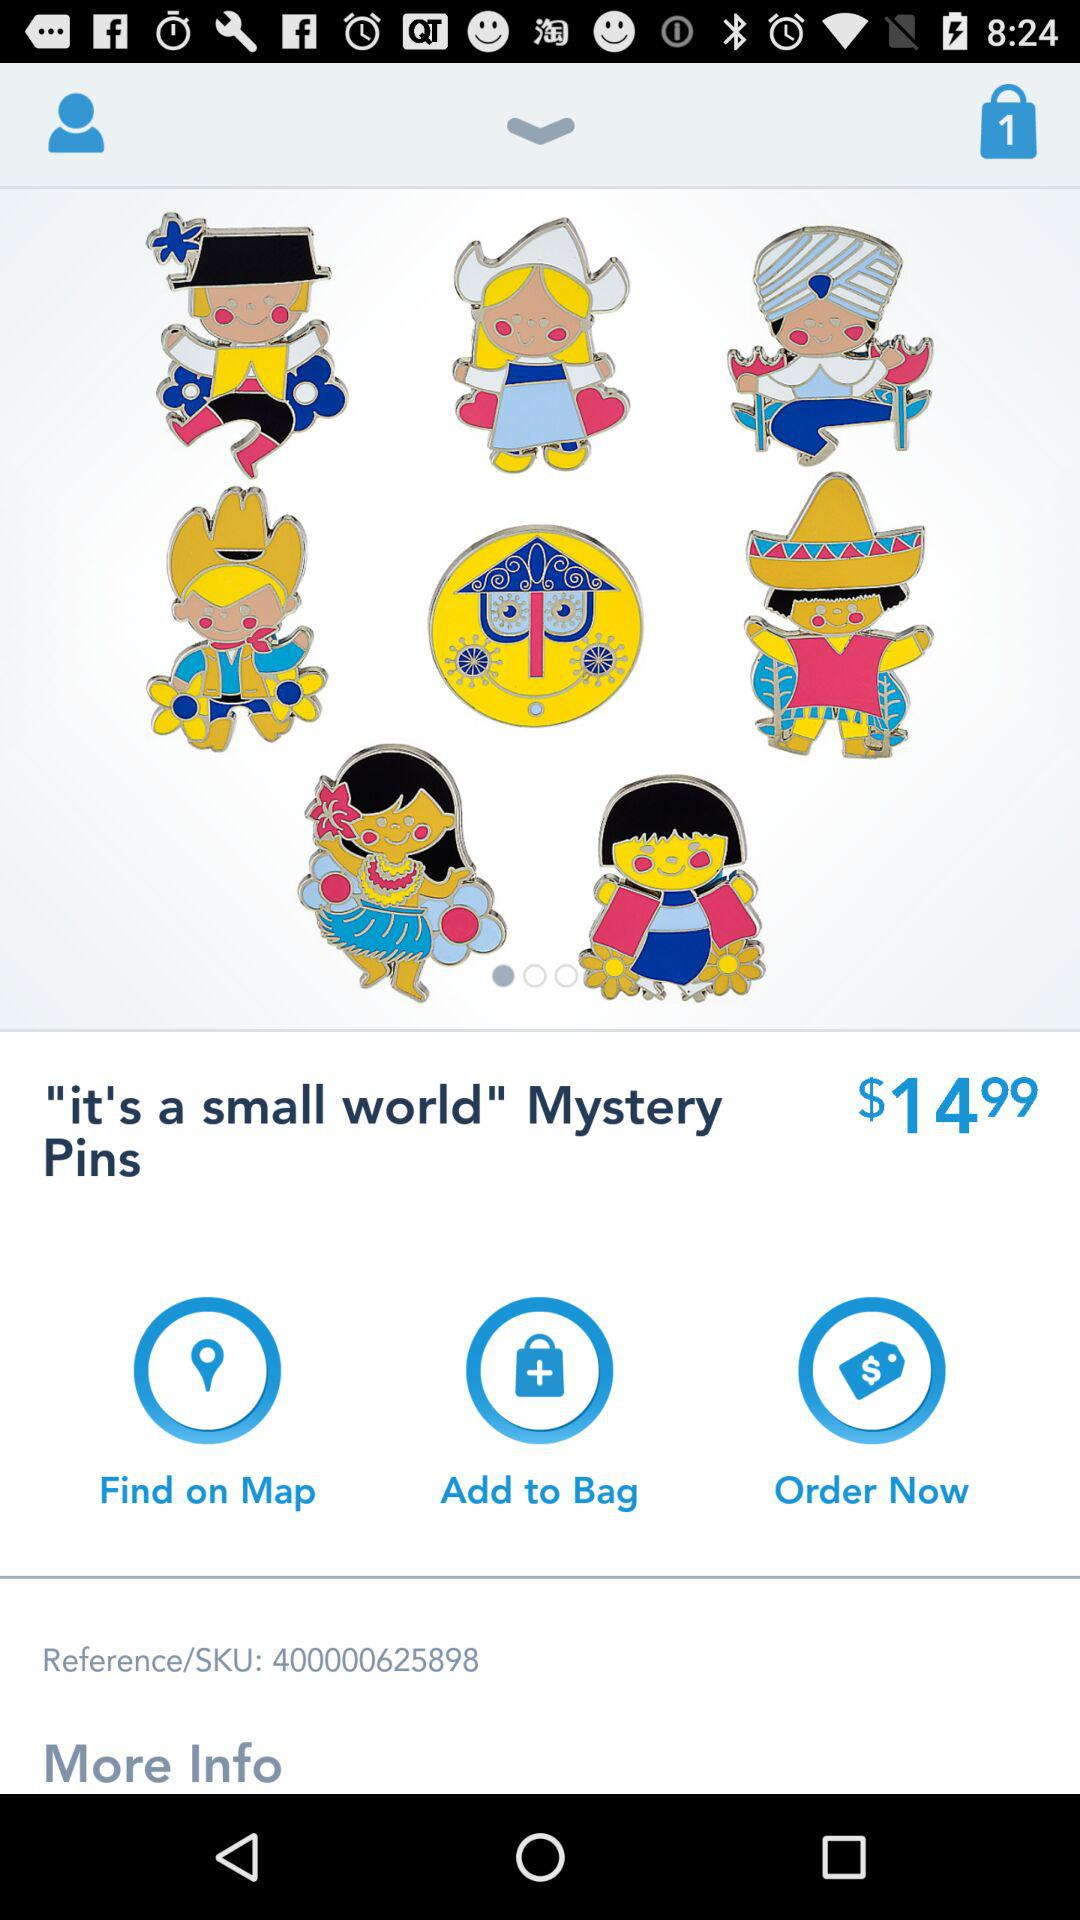What is the number of items in the bag? The number of items in the bag is 1. 